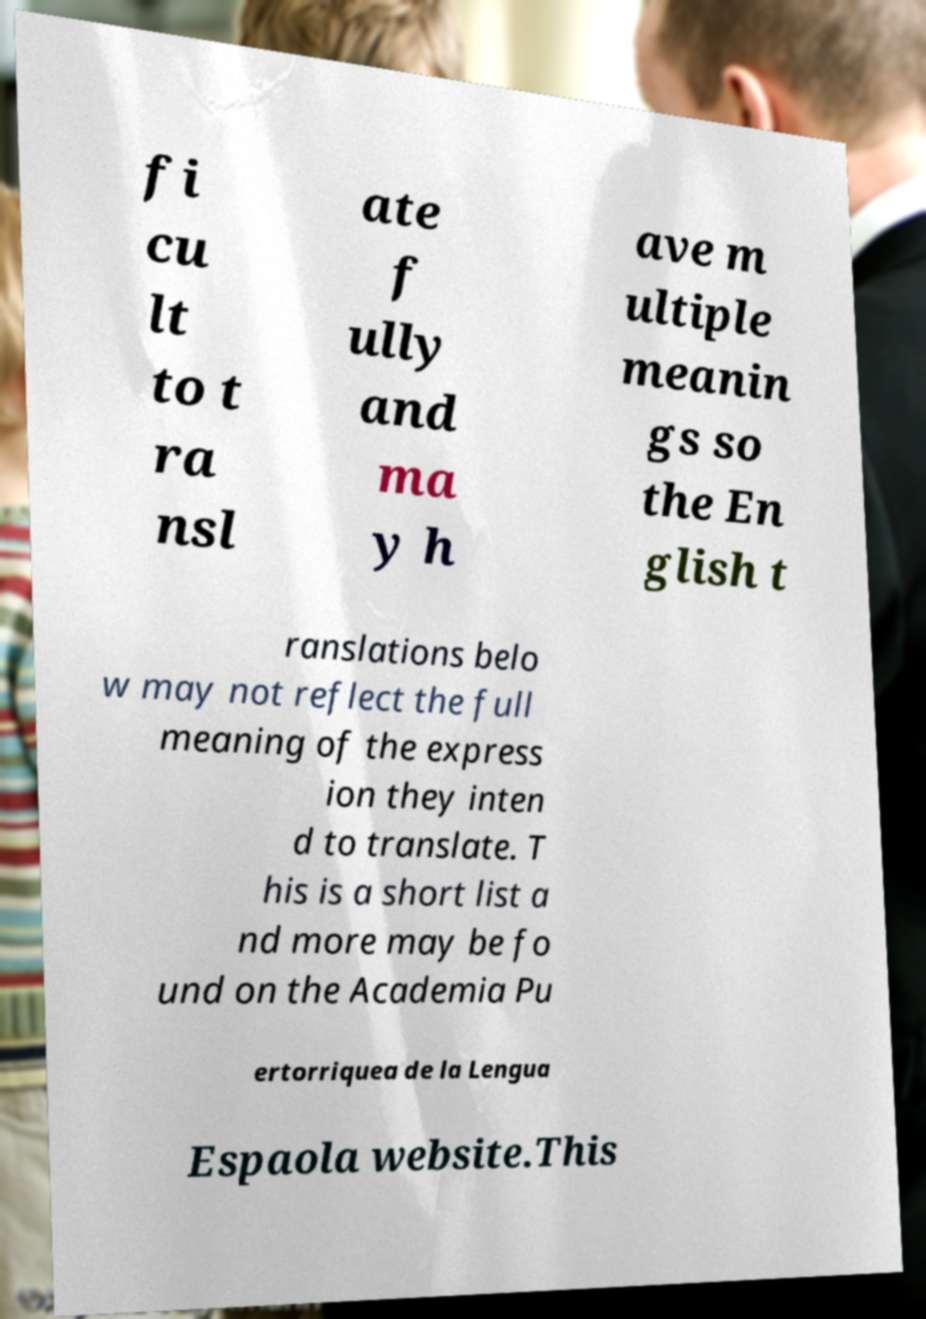Can you accurately transcribe the text from the provided image for me? fi cu lt to t ra nsl ate f ully and ma y h ave m ultiple meanin gs so the En glish t ranslations belo w may not reflect the full meaning of the express ion they inten d to translate. T his is a short list a nd more may be fo und on the Academia Pu ertorriquea de la Lengua Espaola website.This 